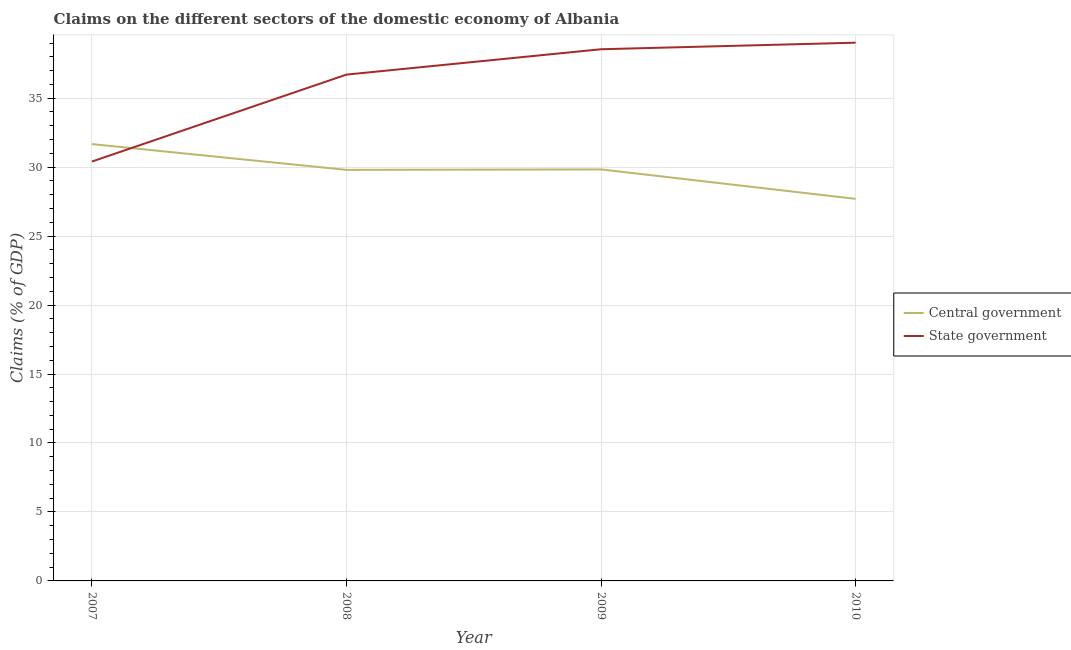Does the line corresponding to claims on state government intersect with the line corresponding to claims on central government?
Make the answer very short. Yes. Is the number of lines equal to the number of legend labels?
Your response must be concise. Yes. What is the claims on state government in 2010?
Ensure brevity in your answer.  39.02. Across all years, what is the maximum claims on central government?
Your answer should be compact. 31.67. Across all years, what is the minimum claims on central government?
Make the answer very short. 27.7. In which year was the claims on state government minimum?
Offer a terse response. 2007. What is the total claims on central government in the graph?
Ensure brevity in your answer.  119.01. What is the difference between the claims on state government in 2007 and that in 2008?
Ensure brevity in your answer.  -6.3. What is the difference between the claims on state government in 2009 and the claims on central government in 2007?
Offer a terse response. 6.88. What is the average claims on central government per year?
Keep it short and to the point. 29.75. In the year 2008, what is the difference between the claims on state government and claims on central government?
Provide a succinct answer. 6.91. What is the ratio of the claims on central government in 2009 to that in 2010?
Your answer should be very brief. 1.08. Is the difference between the claims on central government in 2007 and 2009 greater than the difference between the claims on state government in 2007 and 2009?
Provide a short and direct response. Yes. What is the difference between the highest and the second highest claims on central government?
Ensure brevity in your answer.  1.84. What is the difference between the highest and the lowest claims on central government?
Ensure brevity in your answer.  3.97. Is the claims on state government strictly greater than the claims on central government over the years?
Give a very brief answer. No. How many lines are there?
Your response must be concise. 2. Does the graph contain grids?
Make the answer very short. Yes. What is the title of the graph?
Keep it short and to the point. Claims on the different sectors of the domestic economy of Albania. What is the label or title of the X-axis?
Offer a very short reply. Year. What is the label or title of the Y-axis?
Your answer should be compact. Claims (% of GDP). What is the Claims (% of GDP) in Central government in 2007?
Give a very brief answer. 31.67. What is the Claims (% of GDP) in State government in 2007?
Your answer should be very brief. 30.41. What is the Claims (% of GDP) of Central government in 2008?
Your answer should be compact. 29.8. What is the Claims (% of GDP) in State government in 2008?
Keep it short and to the point. 36.71. What is the Claims (% of GDP) of Central government in 2009?
Your answer should be very brief. 29.83. What is the Claims (% of GDP) of State government in 2009?
Keep it short and to the point. 38.55. What is the Claims (% of GDP) in Central government in 2010?
Give a very brief answer. 27.7. What is the Claims (% of GDP) of State government in 2010?
Keep it short and to the point. 39.02. Across all years, what is the maximum Claims (% of GDP) in Central government?
Give a very brief answer. 31.67. Across all years, what is the maximum Claims (% of GDP) of State government?
Provide a succinct answer. 39.02. Across all years, what is the minimum Claims (% of GDP) in Central government?
Keep it short and to the point. 27.7. Across all years, what is the minimum Claims (% of GDP) of State government?
Your answer should be compact. 30.41. What is the total Claims (% of GDP) of Central government in the graph?
Provide a short and direct response. 119.01. What is the total Claims (% of GDP) of State government in the graph?
Keep it short and to the point. 144.69. What is the difference between the Claims (% of GDP) of Central government in 2007 and that in 2008?
Offer a very short reply. 1.87. What is the difference between the Claims (% of GDP) in State government in 2007 and that in 2008?
Make the answer very short. -6.3. What is the difference between the Claims (% of GDP) of Central government in 2007 and that in 2009?
Make the answer very short. 1.84. What is the difference between the Claims (% of GDP) in State government in 2007 and that in 2009?
Keep it short and to the point. -8.14. What is the difference between the Claims (% of GDP) in Central government in 2007 and that in 2010?
Ensure brevity in your answer.  3.97. What is the difference between the Claims (% of GDP) in State government in 2007 and that in 2010?
Your answer should be compact. -8.62. What is the difference between the Claims (% of GDP) of Central government in 2008 and that in 2009?
Your answer should be very brief. -0.03. What is the difference between the Claims (% of GDP) of State government in 2008 and that in 2009?
Provide a succinct answer. -1.84. What is the difference between the Claims (% of GDP) of Central government in 2008 and that in 2010?
Your answer should be very brief. 2.1. What is the difference between the Claims (% of GDP) of State government in 2008 and that in 2010?
Provide a short and direct response. -2.31. What is the difference between the Claims (% of GDP) of Central government in 2009 and that in 2010?
Give a very brief answer. 2.13. What is the difference between the Claims (% of GDP) of State government in 2009 and that in 2010?
Offer a terse response. -0.48. What is the difference between the Claims (% of GDP) of Central government in 2007 and the Claims (% of GDP) of State government in 2008?
Your response must be concise. -5.04. What is the difference between the Claims (% of GDP) of Central government in 2007 and the Claims (% of GDP) of State government in 2009?
Make the answer very short. -6.88. What is the difference between the Claims (% of GDP) in Central government in 2007 and the Claims (% of GDP) in State government in 2010?
Offer a very short reply. -7.35. What is the difference between the Claims (% of GDP) of Central government in 2008 and the Claims (% of GDP) of State government in 2009?
Your answer should be compact. -8.75. What is the difference between the Claims (% of GDP) of Central government in 2008 and the Claims (% of GDP) of State government in 2010?
Your answer should be very brief. -9.22. What is the difference between the Claims (% of GDP) in Central government in 2009 and the Claims (% of GDP) in State government in 2010?
Keep it short and to the point. -9.19. What is the average Claims (% of GDP) of Central government per year?
Your answer should be very brief. 29.75. What is the average Claims (% of GDP) in State government per year?
Ensure brevity in your answer.  36.17. In the year 2007, what is the difference between the Claims (% of GDP) in Central government and Claims (% of GDP) in State government?
Your answer should be compact. 1.27. In the year 2008, what is the difference between the Claims (% of GDP) of Central government and Claims (% of GDP) of State government?
Ensure brevity in your answer.  -6.91. In the year 2009, what is the difference between the Claims (% of GDP) of Central government and Claims (% of GDP) of State government?
Offer a very short reply. -8.71. In the year 2010, what is the difference between the Claims (% of GDP) of Central government and Claims (% of GDP) of State government?
Offer a very short reply. -11.32. What is the ratio of the Claims (% of GDP) in Central government in 2007 to that in 2008?
Offer a very short reply. 1.06. What is the ratio of the Claims (% of GDP) of State government in 2007 to that in 2008?
Your response must be concise. 0.83. What is the ratio of the Claims (% of GDP) of Central government in 2007 to that in 2009?
Offer a very short reply. 1.06. What is the ratio of the Claims (% of GDP) of State government in 2007 to that in 2009?
Your answer should be compact. 0.79. What is the ratio of the Claims (% of GDP) of Central government in 2007 to that in 2010?
Keep it short and to the point. 1.14. What is the ratio of the Claims (% of GDP) in State government in 2007 to that in 2010?
Offer a very short reply. 0.78. What is the ratio of the Claims (% of GDP) of Central government in 2008 to that in 2009?
Your response must be concise. 1. What is the ratio of the Claims (% of GDP) of State government in 2008 to that in 2009?
Give a very brief answer. 0.95. What is the ratio of the Claims (% of GDP) in Central government in 2008 to that in 2010?
Keep it short and to the point. 1.08. What is the ratio of the Claims (% of GDP) of State government in 2008 to that in 2010?
Offer a terse response. 0.94. What is the ratio of the Claims (% of GDP) of Central government in 2009 to that in 2010?
Offer a terse response. 1.08. What is the ratio of the Claims (% of GDP) in State government in 2009 to that in 2010?
Offer a very short reply. 0.99. What is the difference between the highest and the second highest Claims (% of GDP) of Central government?
Keep it short and to the point. 1.84. What is the difference between the highest and the second highest Claims (% of GDP) of State government?
Ensure brevity in your answer.  0.48. What is the difference between the highest and the lowest Claims (% of GDP) of Central government?
Your answer should be very brief. 3.97. What is the difference between the highest and the lowest Claims (% of GDP) of State government?
Offer a terse response. 8.62. 